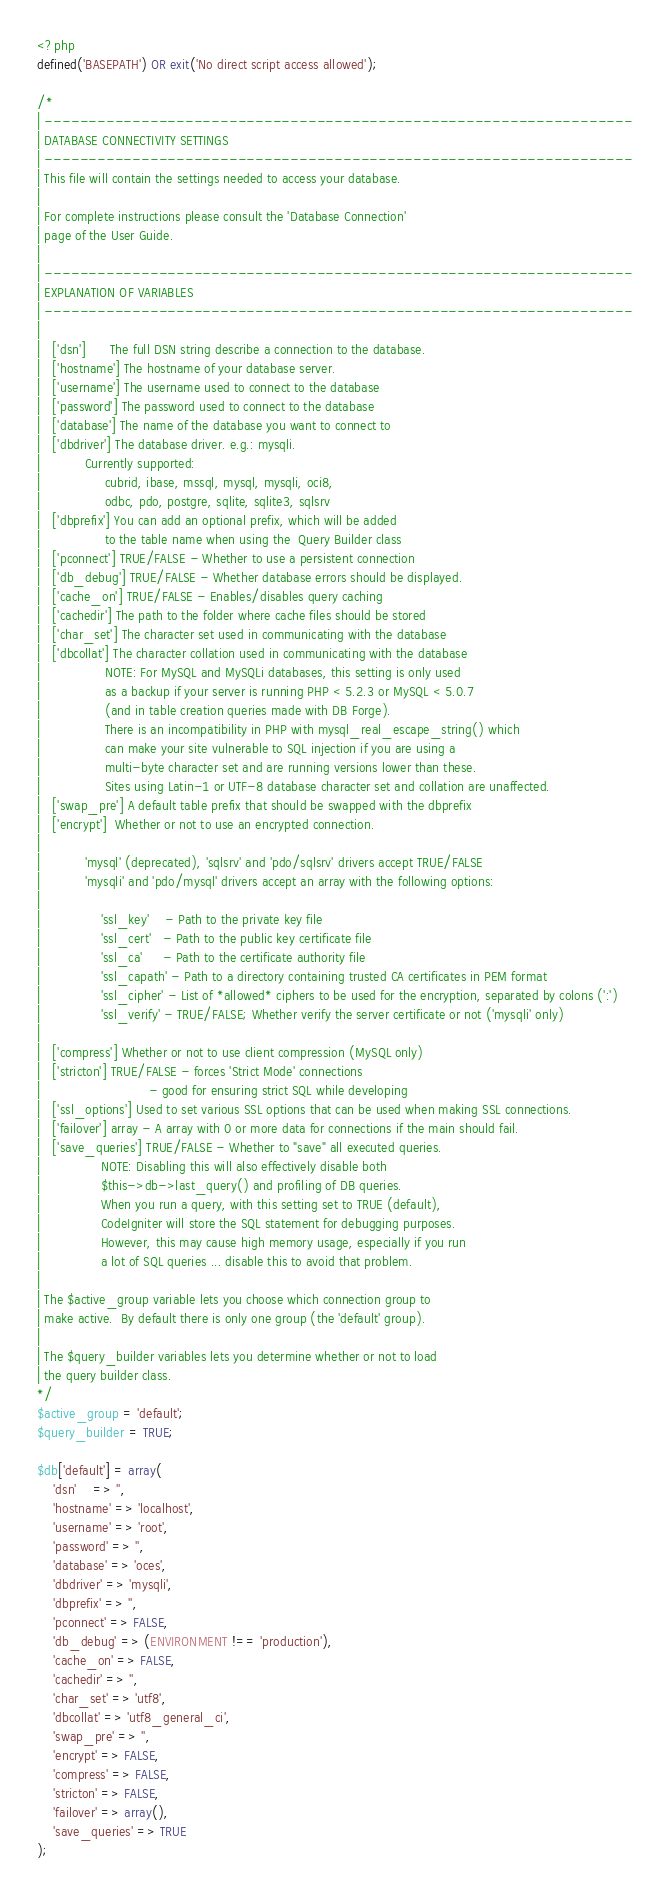<code> <loc_0><loc_0><loc_500><loc_500><_PHP_><?php
defined('BASEPATH') OR exit('No direct script access allowed');

/*
| -------------------------------------------------------------------
| DATABASE CONNECTIVITY SETTINGS
| -------------------------------------------------------------------
| This file will contain the settings needed to access your database.
|
| For complete instructions please consult the 'Database Connection'
| page of the User Guide.
|
| -------------------------------------------------------------------
| EXPLANATION OF VARIABLES
| -------------------------------------------------------------------
|
|	['dsn']      The full DSN string describe a connection to the database.
|	['hostname'] The hostname of your database server.
|	['username'] The username used to connect to the database
|	['password'] The password used to connect to the database
|	['database'] The name of the database you want to connect to
|	['dbdriver'] The database driver. e.g.: mysqli.
|			Currently supported:
|				 cubrid, ibase, mssql, mysql, mysqli, oci8,
|				 odbc, pdo, postgre, sqlite, sqlite3, sqlsrv
|	['dbprefix'] You can add an optional prefix, which will be added
|				 to the table name when using the  Query Builder class
|	['pconnect'] TRUE/FALSE - Whether to use a persistent connection
|	['db_debug'] TRUE/FALSE - Whether database errors should be displayed.
|	['cache_on'] TRUE/FALSE - Enables/disables query caching
|	['cachedir'] The path to the folder where cache files should be stored
|	['char_set'] The character set used in communicating with the database
|	['dbcollat'] The character collation used in communicating with the database
|				 NOTE: For MySQL and MySQLi databases, this setting is only used
| 				 as a backup if your server is running PHP < 5.2.3 or MySQL < 5.0.7
|				 (and in table creation queries made with DB Forge).
| 				 There is an incompatibility in PHP with mysql_real_escape_string() which
| 				 can make your site vulnerable to SQL injection if you are using a
| 				 multi-byte character set and are running versions lower than these.
| 				 Sites using Latin-1 or UTF-8 database character set and collation are unaffected.
|	['swap_pre'] A default table prefix that should be swapped with the dbprefix
|	['encrypt']  Whether or not to use an encrypted connection.
|
|			'mysql' (deprecated), 'sqlsrv' and 'pdo/sqlsrv' drivers accept TRUE/FALSE
|			'mysqli' and 'pdo/mysql' drivers accept an array with the following options:
|
|				'ssl_key'    - Path to the private key file
|				'ssl_cert'   - Path to the public key certificate file
|				'ssl_ca'     - Path to the certificate authority file
|				'ssl_capath' - Path to a directory containing trusted CA certificates in PEM format
|				'ssl_cipher' - List of *allowed* ciphers to be used for the encryption, separated by colons (':')
|				'ssl_verify' - TRUE/FALSE; Whether verify the server certificate or not ('mysqli' only)
|
|	['compress'] Whether or not to use client compression (MySQL only)
|	['stricton'] TRUE/FALSE - forces 'Strict Mode' connections
|							- good for ensuring strict SQL while developing
|	['ssl_options']	Used to set various SSL options that can be used when making SSL connections.
|	['failover'] array - A array with 0 or more data for connections if the main should fail.
|	['save_queries'] TRUE/FALSE - Whether to "save" all executed queries.
| 				NOTE: Disabling this will also effectively disable both
| 				$this->db->last_query() and profiling of DB queries.
| 				When you run a query, with this setting set to TRUE (default),
| 				CodeIgniter will store the SQL statement for debugging purposes.
| 				However, this may cause high memory usage, especially if you run
| 				a lot of SQL queries ... disable this to avoid that problem.
|
| The $active_group variable lets you choose which connection group to
| make active.  By default there is only one group (the 'default' group).
|
| The $query_builder variables lets you determine whether or not to load
| the query builder class.
*/
$active_group = 'default';
$query_builder = TRUE;

$db['default'] = array(
	'dsn'	=> '',
	'hostname' => 'localhost',
	'username' => 'root',
	'password' => '',
	'database' => 'oces',
	'dbdriver' => 'mysqli',
	'dbprefix' => '',
	'pconnect' => FALSE,
	'db_debug' => (ENVIRONMENT !== 'production'),
	'cache_on' => FALSE,
	'cachedir' => '',
	'char_set' => 'utf8',
	'dbcollat' => 'utf8_general_ci',
	'swap_pre' => '',
	'encrypt' => FALSE,
	'compress' => FALSE,
	'stricton' => FALSE,
	'failover' => array(),
	'save_queries' => TRUE
);
</code> 